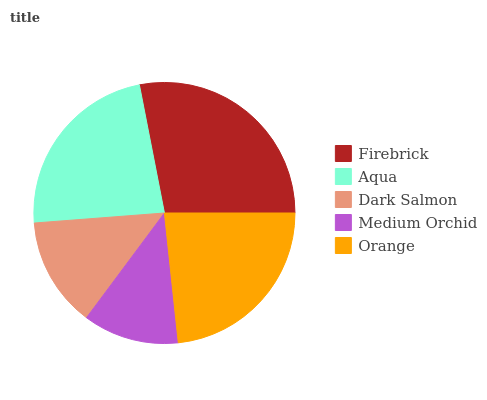Is Medium Orchid the minimum?
Answer yes or no. Yes. Is Firebrick the maximum?
Answer yes or no. Yes. Is Aqua the minimum?
Answer yes or no. No. Is Aqua the maximum?
Answer yes or no. No. Is Firebrick greater than Aqua?
Answer yes or no. Yes. Is Aqua less than Firebrick?
Answer yes or no. Yes. Is Aqua greater than Firebrick?
Answer yes or no. No. Is Firebrick less than Aqua?
Answer yes or no. No. Is Aqua the high median?
Answer yes or no. Yes. Is Aqua the low median?
Answer yes or no. Yes. Is Dark Salmon the high median?
Answer yes or no. No. Is Medium Orchid the low median?
Answer yes or no. No. 